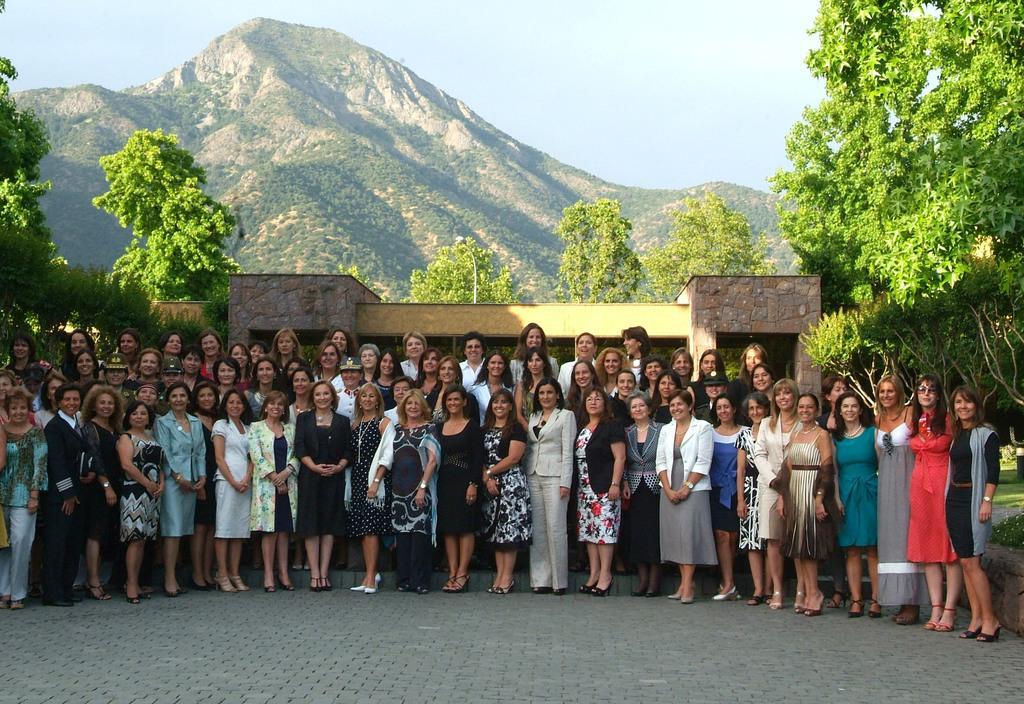How would you summarize this image in a sentence or two? In this image I can see a group of women's are standing on the floor. In the background I can see a building, trees, mountains and the sky. This image is taken may be during a sunny day. 